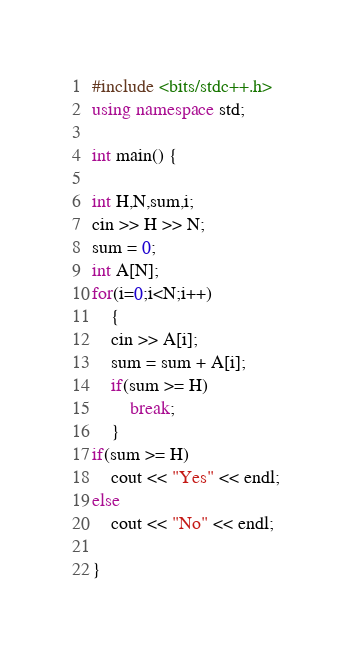<code> <loc_0><loc_0><loc_500><loc_500><_C++_>#include <bits/stdc++.h>
using namespace std;
 
int main() {

int H,N,sum,i;
cin >> H >> N;
sum = 0;
int A[N];
for(i=0;i<N;i++)
	{
	cin >> A[i];
	sum = sum + A[i];
	if(sum >= H)
		break;
	}
if(sum >= H)
	cout << "Yes" << endl;
else
	cout << "No" << endl;

}</code> 